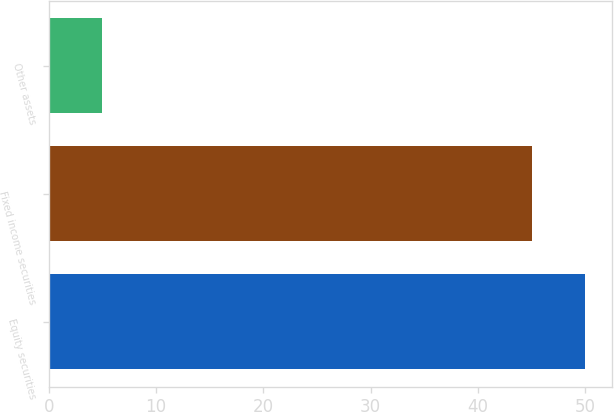Convert chart to OTSL. <chart><loc_0><loc_0><loc_500><loc_500><bar_chart><fcel>Equity securities<fcel>Fixed income securities<fcel>Other assets<nl><fcel>50<fcel>45<fcel>5<nl></chart> 